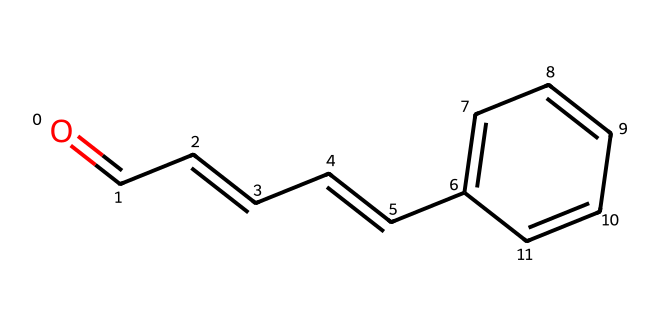What is the molecular formula of cinnamaldehyde? To derive the molecular formula from the SMILES representation, we identify the atoms present in the structure. By examining the SMILES, the components include 9 carbon atoms (C), 8 hydrogen atoms (H), and 1 oxygen atom (O). Thus, the molecular formula is C9H8O.
Answer: C9H8O How many rings are present in this structure? In the provided SMILES, there is one aromatic ring indicated by 'C1=CC=CC=C1', which signifies a cyclic structure. The remaining atoms do not form additional rings. Thus, the total is one ring.
Answer: 1 What type of functional group characterizes this compound? The functional group is indicated by the 'O=' at the beginning, which denotes a carbonyl group, specifically an aldehyde since it is attached to a carbon chain ending in a hydrogen atom. Aldehydes are recognizable by this carbonyl group at the terminal position of a carbon chain.
Answer: aldehyde What is the degree of unsaturation in this compound? To calculate the degree of unsaturation, we apply the formula: (2C + 2 + N - H - X)/2. In this case, with 9 carbons (C), 8 hydrogens (H), and no nitrogen (N) or halogens (X), we calculate: (2*9 + 2 - 8)/2 = 6. This indicates that there are 6 degrees of unsaturation, which accounts for the presence of rings and/or double bonds in the structure.
Answer: 6 What is the significance of the double bonds in this compound? The structure contains multiple double bonds, specifically in the carbon chain with the 'CC=C' and 'C=O' parts. These double bonds play a significant role in the compound's reactivity and stability, affecting its chemical properties, including its flavor and aroma. In this case, they contribute to the characteristics of cinnamaldehyde, which is essential for scents and flavors.
Answer: reactivity and stability 